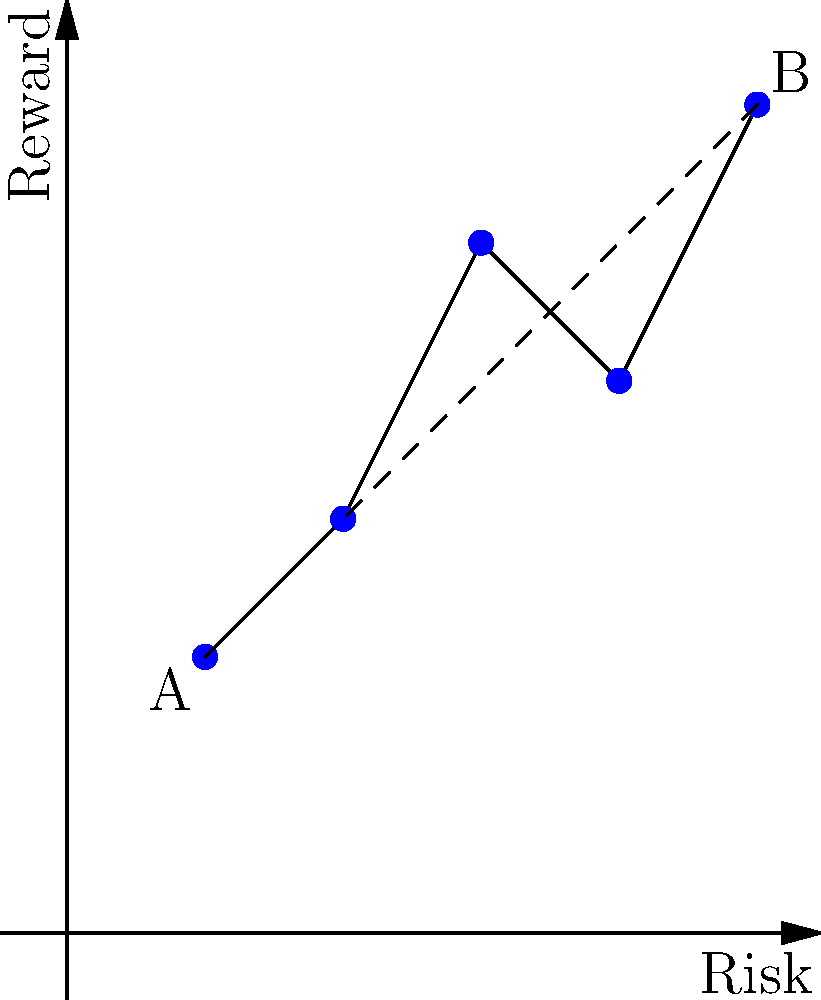In the risk-reward scatter plot above, points A and B represent two investment options. If each unit on the x-axis represents 2% of risk and each unit on the y-axis represents 3% of reward, what is the Euclidean distance between these two investment options in terms of percentage difference? To solve this problem, we'll follow these steps:

1) First, identify the coordinates of points A and B:
   A: (1, 2)
   B: (5, 6)

2) Calculate the differences in x and y coordinates:
   x difference: 5 - 1 = 4 units
   y difference: 6 - 2 = 4 units

3) Convert these differences to percentages:
   x difference in %: 4 * 2% = 8% (risk)
   y difference in %: 4 * 3% = 12% (reward)

4) Use the Euclidean distance formula:
   $$d = \sqrt{(\text{risk difference})^2 + (\text{reward difference})^2}$$

5) Plug in the percentage differences:
   $$d = \sqrt{8^2 + 12^2}$$

6) Calculate:
   $$d = \sqrt{64 + 144} = \sqrt{208} = 14.42\%$$

Therefore, the Euclidean distance between the two investment options is approximately 14.42% in terms of combined risk and reward difference.
Answer: 14.42% 